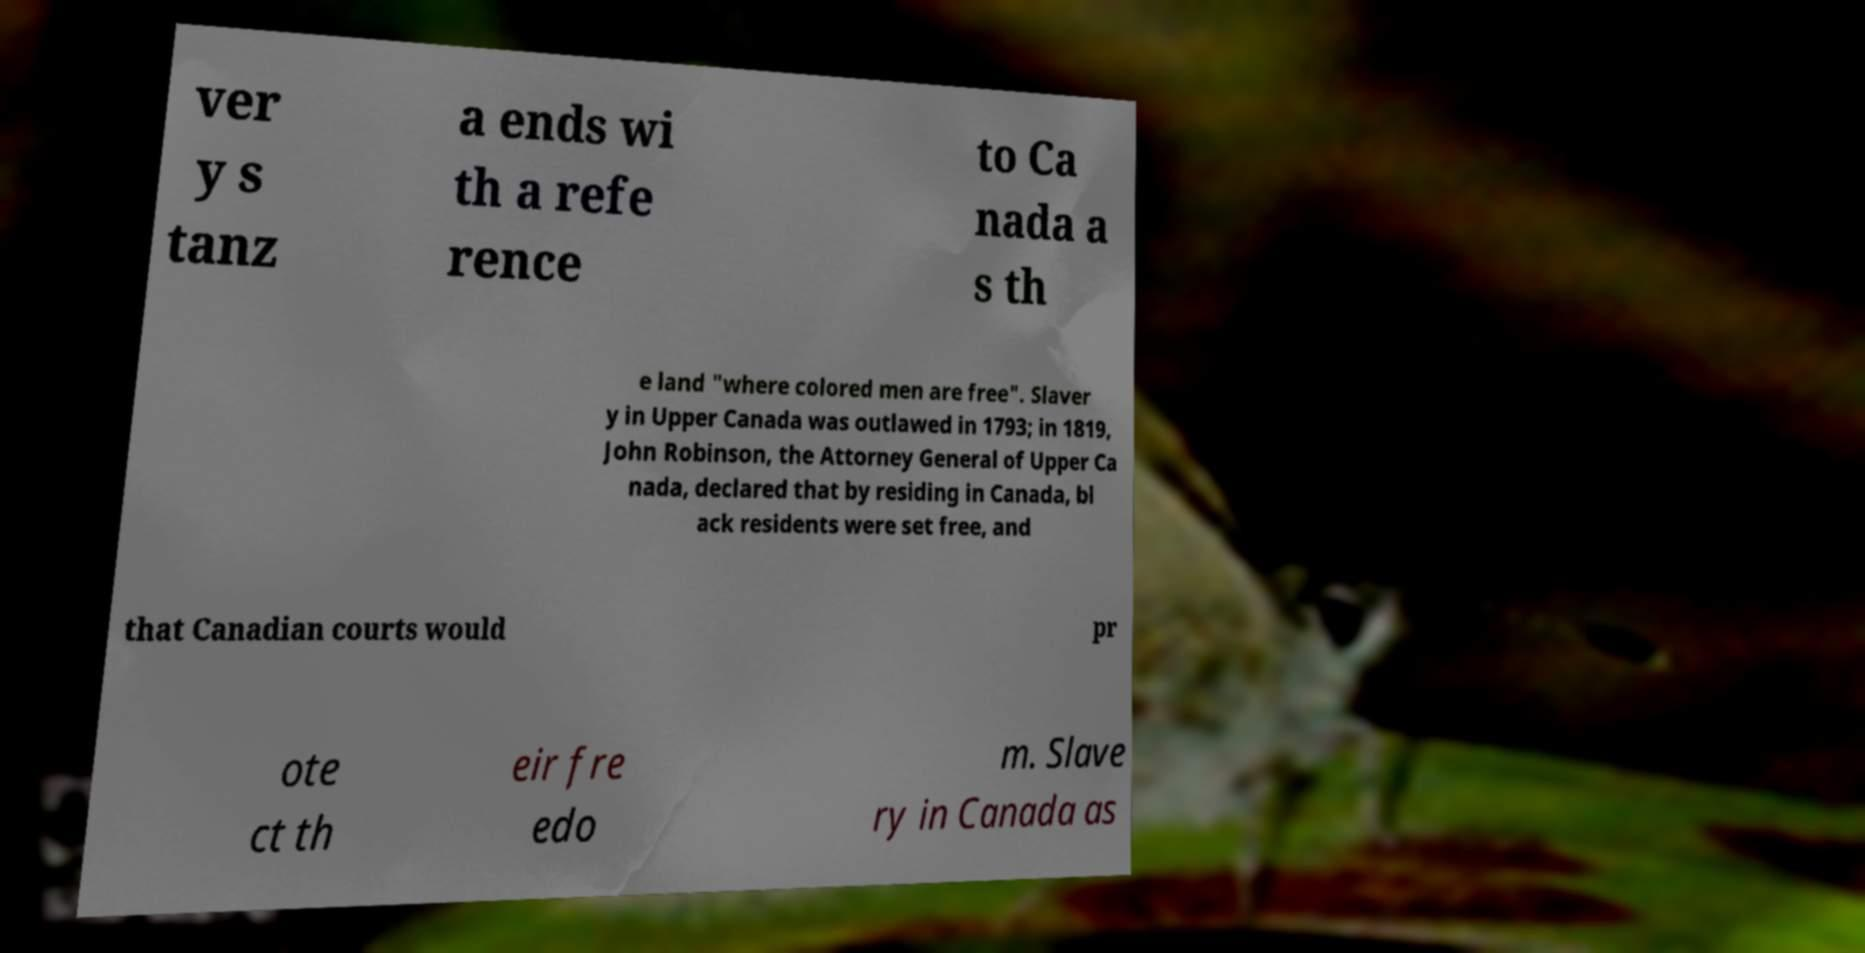Can you accurately transcribe the text from the provided image for me? ver y s tanz a ends wi th a refe rence to Ca nada a s th e land "where colored men are free". Slaver y in Upper Canada was outlawed in 1793; in 1819, John Robinson, the Attorney General of Upper Ca nada, declared that by residing in Canada, bl ack residents were set free, and that Canadian courts would pr ote ct th eir fre edo m. Slave ry in Canada as 